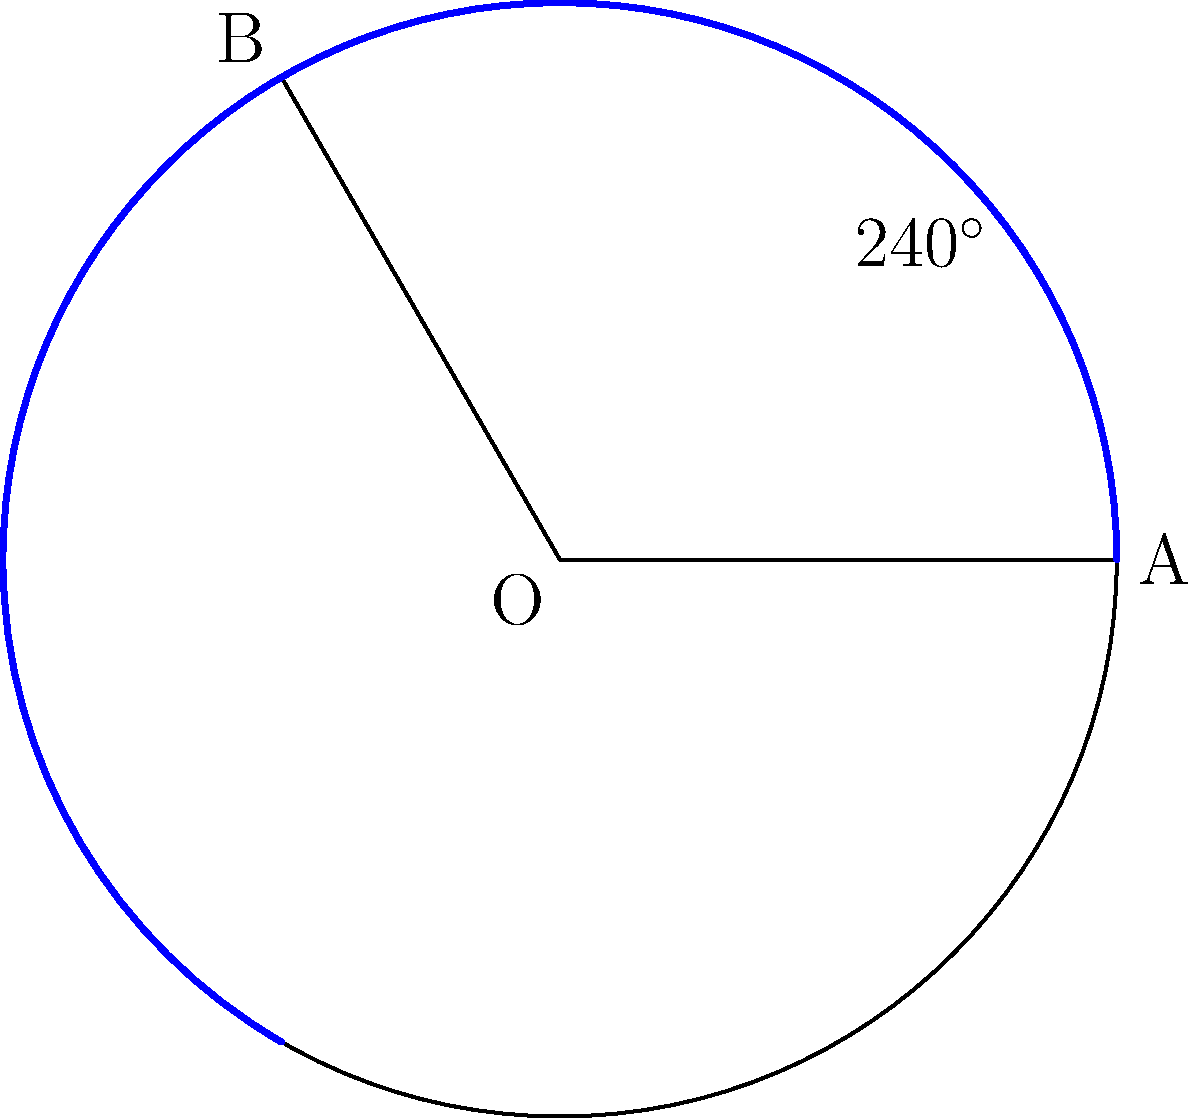Remember those glorious championship years for Northwestern Lehigh? The sector in blue represents the angle subtended by those victorious seasons. If the radius of the circle is 10 units, what is the area of the sector representing our championship years? Let's approach this step-by-step:

1) The formula for the area of a sector is:
   $$A = \frac{\theta}{360^\circ} \cdot \pi r^2$$
   where $\theta$ is the central angle in degrees and $r$ is the radius.

2) From the diagram, we can see that the central angle is $240^\circ$.

3) We're given that the radius is 10 units.

4) Let's substitute these values into our formula:
   $$A = \frac{240^\circ}{360^\circ} \cdot \pi (10)^2$$

5) Simplify:
   $$A = \frac{2}{3} \cdot \pi \cdot 100$$

6) Calculate:
   $$A = \frac{200\pi}{3} \approx 209.44$$

Therefore, the area of the sector is $\frac{200\pi}{3}$ square units, or approximately 209.44 square units.
Answer: $\frac{200\pi}{3}$ square units 